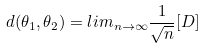Convert formula to latex. <formula><loc_0><loc_0><loc_500><loc_500>d ( \theta _ { 1 } , \theta _ { 2 } ) = l i m _ { n \rightarrow \infty } \frac { 1 } { \sqrt { n } } [ D ]</formula> 